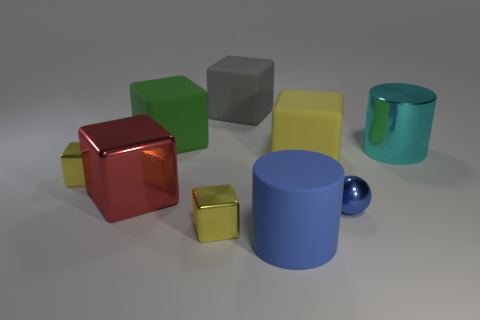Subtract all blue spheres. How many yellow cubes are left? 3 Subtract all gray blocks. How many blocks are left? 5 Subtract all large shiny blocks. How many blocks are left? 5 Subtract all red blocks. Subtract all cyan spheres. How many blocks are left? 5 Subtract all cylinders. How many objects are left? 7 Add 5 blue shiny objects. How many blue shiny objects are left? 6 Add 3 gray objects. How many gray objects exist? 4 Subtract 3 yellow cubes. How many objects are left? 6 Subtract all large green objects. Subtract all green matte objects. How many objects are left? 7 